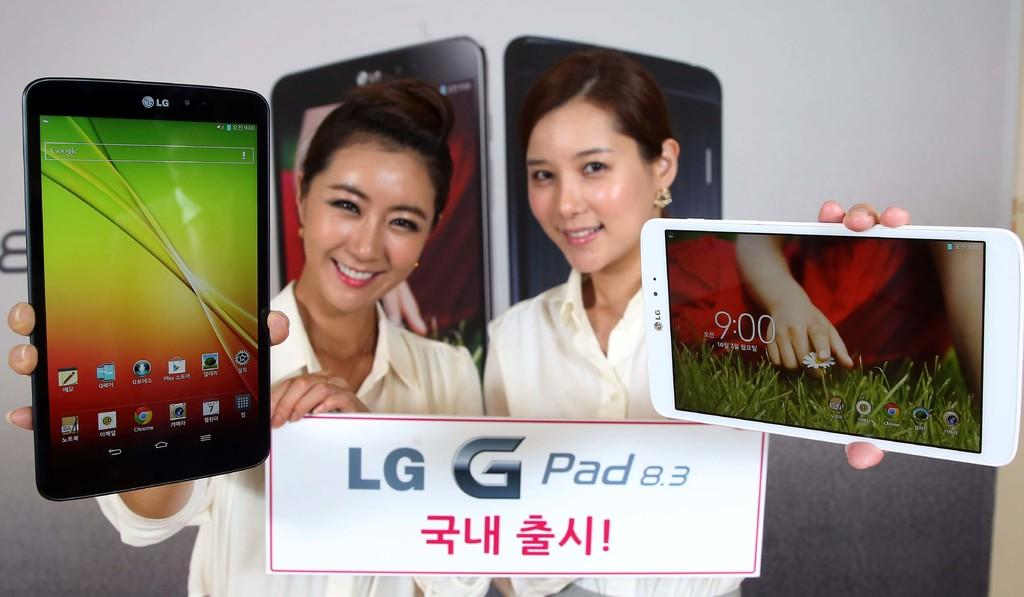How many people are in the image? There are two women in the image. What is the facial expression of the women? The women are smiling. What are the women holding in their hands? The women are holding a mobile with their hands. What type of rock can be seen in the image? There is no rock present in the image; it features two women holding a mobile. 